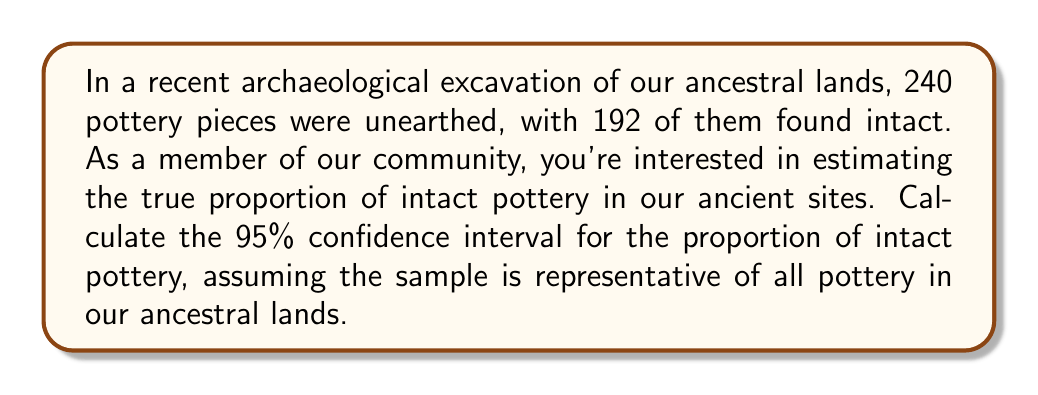Teach me how to tackle this problem. Let's approach this step-by-step:

1) First, we need to calculate the sample proportion $\hat{p}$:
   $\hat{p} = \frac{\text{number of intact pieces}}{\text{total number of pieces}} = \frac{192}{240} = 0.8$

2) The formula for the confidence interval of a proportion is:
   $$\hat{p} \pm z_{\alpha/2} \sqrt{\frac{\hat{p}(1-\hat{p})}{n}}$$
   where $z_{\alpha/2}$ is the critical value for the desired confidence level, and $n$ is the sample size.

3) For a 95% confidence interval, $z_{\alpha/2} = 1.96$

4) Now, let's substitute our values:
   $n = 240$
   $\hat{p} = 0.8$

5) Calculate the standard error:
   $$\sqrt{\frac{\hat{p}(1-\hat{p})}{n}} = \sqrt{\frac{0.8(1-0.8)}{240}} = \sqrt{\frac{0.16}{240}} \approx 0.0258$$

6) Now we can calculate the margin of error:
   $$1.96 \times 0.0258 \approx 0.0506$$

7) Finally, we can calculate the confidence interval:
   $0.8 \pm 0.0506$
   
   Lower bound: $0.8 - 0.0506 = 0.7494$
   Upper bound: $0.8 + 0.0506 = 0.8506$

Therefore, we are 95% confident that the true proportion of intact pottery in our ancestral lands is between 0.7494 and 0.8506, or approximately between 74.94% and 85.06%.
Answer: (0.7494, 0.8506) 